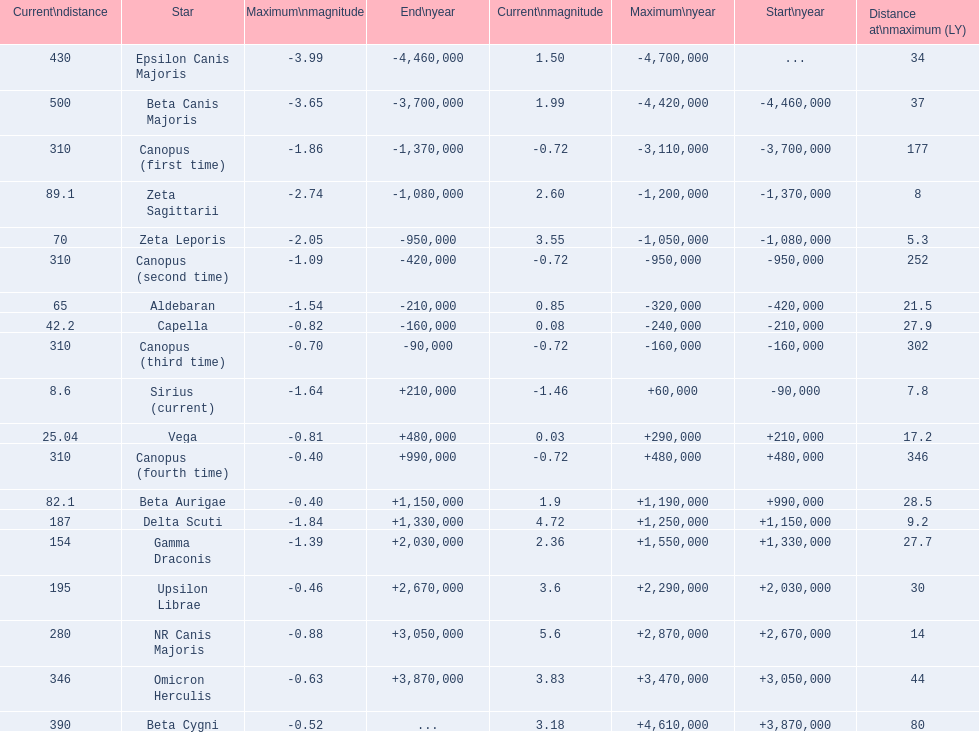What are all the stars? Epsilon Canis Majoris, Beta Canis Majoris, Canopus (first time), Zeta Sagittarii, Zeta Leporis, Canopus (second time), Aldebaran, Capella, Canopus (third time), Sirius (current), Vega, Canopus (fourth time), Beta Aurigae, Delta Scuti, Gamma Draconis, Upsilon Librae, NR Canis Majoris, Omicron Herculis, Beta Cygni. Of those, which star has a maximum distance of 80? Beta Cygni. 